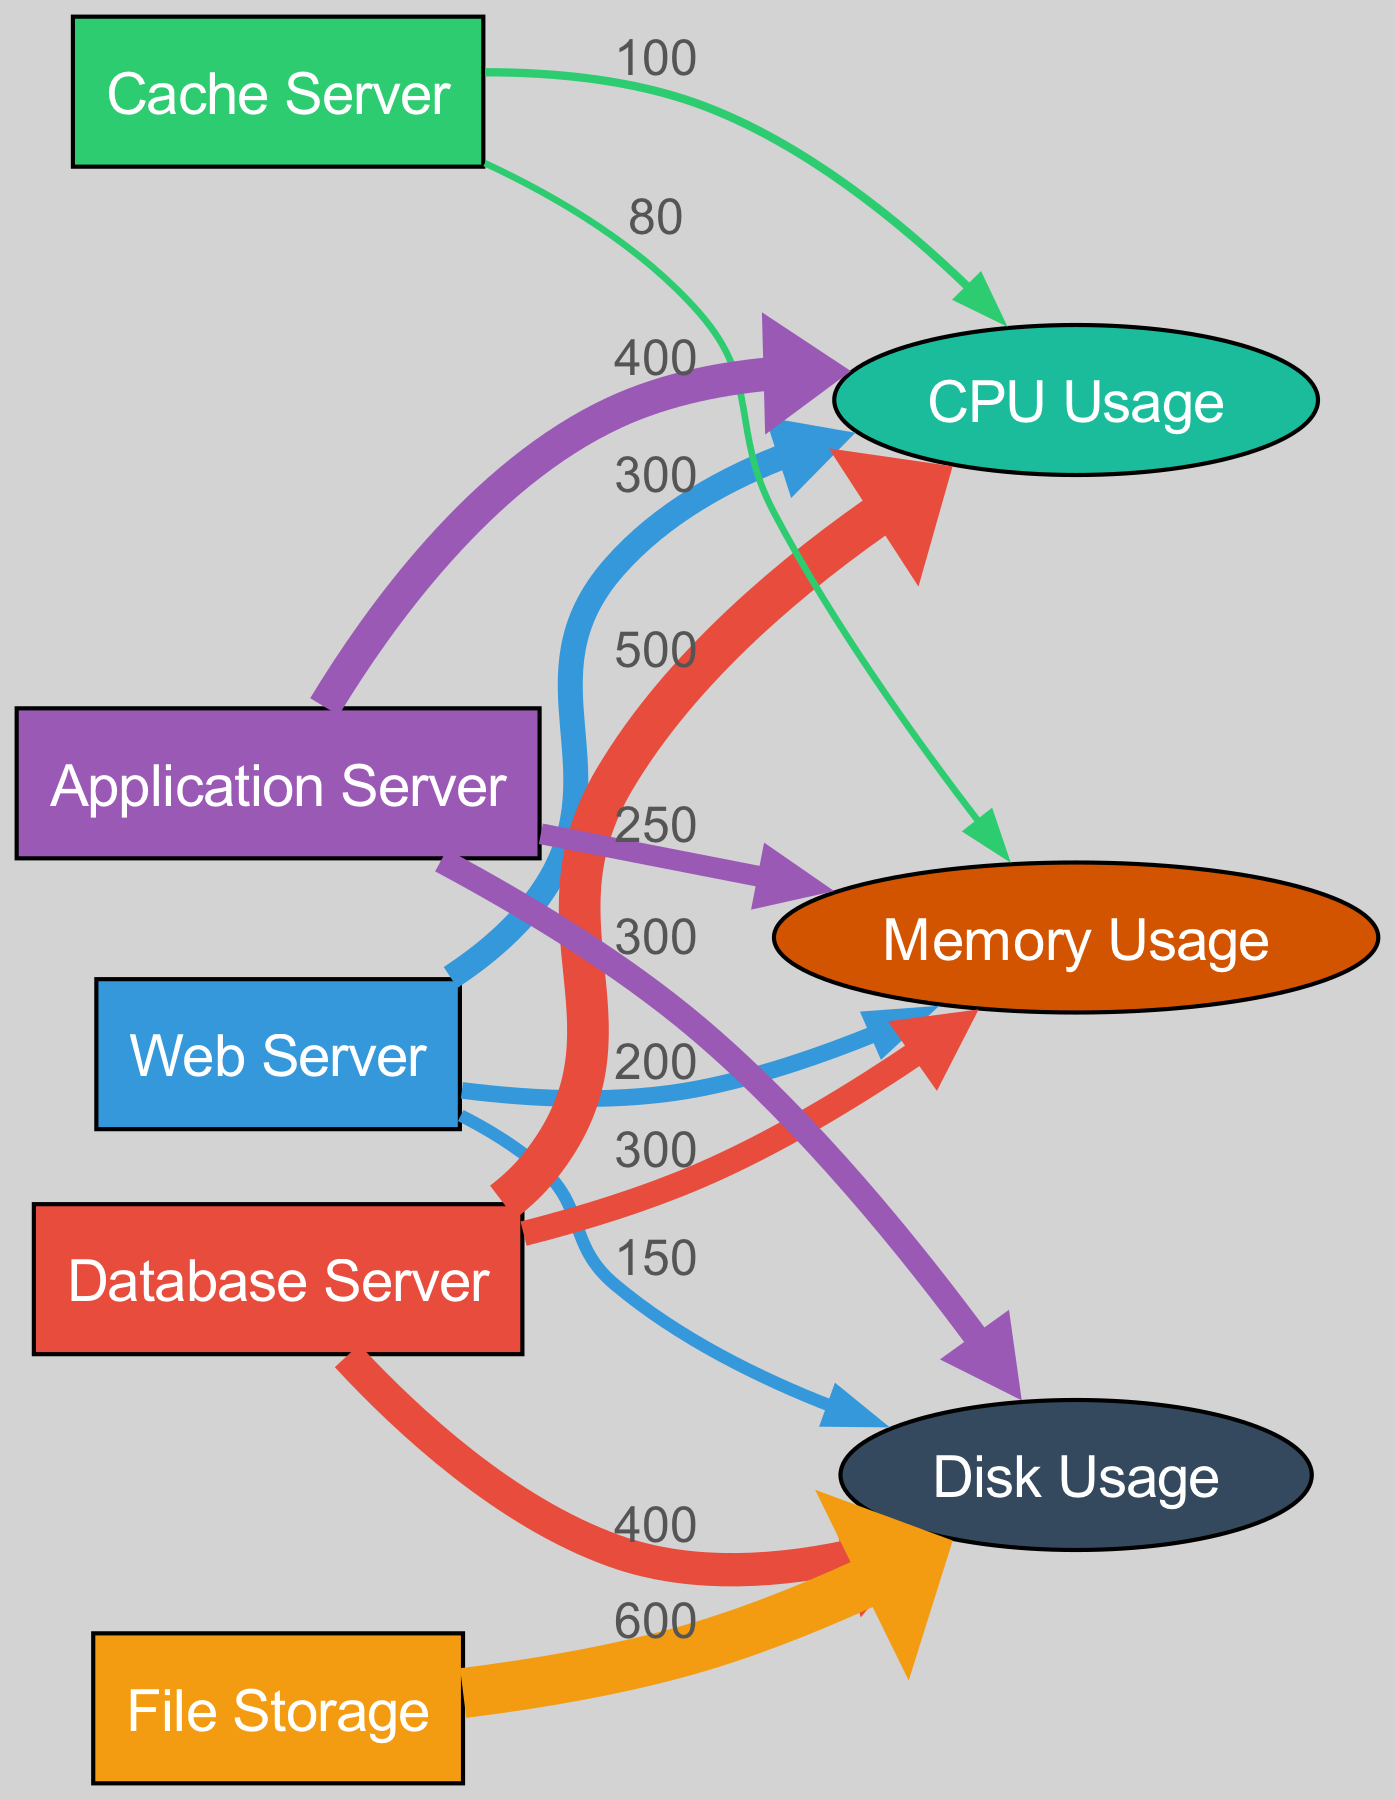What is the total CPU usage across all services? First, identify the CPU usage values for each service: Web Server (300), Database Server (500), Cache Server (100), Application Server (400). Then, sum these values: 300 + 500 + 100 + 400 = 1300.
Answer: 1300 Which service uses the most memory? Look at the memory usage values for each service: Web Server (200), Database Server (300), Cache Server (80), Application Server (250). The Database Server has the highest value at 300.
Answer: Database Server How many services are represented in the diagram? Count the number of nodes that represent services: Web Server, Database Server, Cache Server, File Storage, Application Server. This totals to 5 services.
Answer: 5 What is the disk usage by File Storage? Check the link between File Storage and Disk Usage. The value for Disk Usage from File Storage is 600.
Answer: 600 What is the combined memory usage of Web Server and Cache Server? Identify the memory usage for both services: Web Server (200) and Cache Server (80). Then, combine these two values: 200 + 80 = 280.
Answer: 280 Which resource has the highest total usage across all services? First, sum the values for each resource: CPU Usage (Web Server 300 + Database Server 500 + Cache Server 100 + Application Server 400 = 1300), Memory Usage (Web Server 200 + Database Server 300 + Cache Server 80 + Application Server 250 = 830), Disk Usage (Web Server 150 + Database Server 400 + File Storage 600 + Application Server 300 = 1450). Comparing the totals, Disk Usage (1450) is the highest.
Answer: Disk Usage How many links connect the Application Server to resource usage? Count the links from the Application Server: 3 links connect it to CPU Usage, Memory Usage, and Disk Usage.
Answer: 3 What percentage of the total CPU usage is from the Database Server? The total CPU usage is 1300. The Database Server uses 500 CPU. Calculate the percentage: (500 / 1300) * 100 = 38.46%.
Answer: 38.46 percent What is the minimum memory usage among all services? Look at the memory usage values: Web Server (200), Database Server (300), Cache Server (80), Application Server (250). The minimum value is 80 (from Cache Server).
Answer: 80 